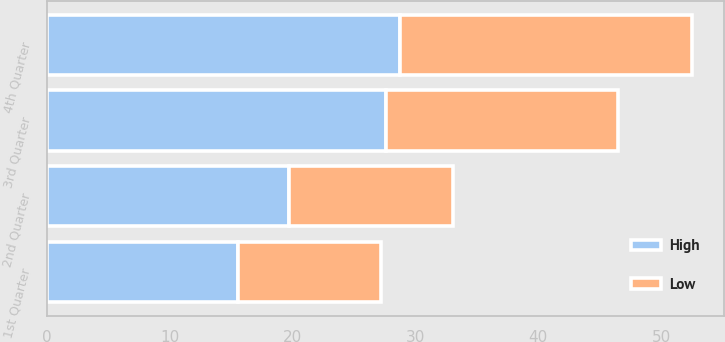<chart> <loc_0><loc_0><loc_500><loc_500><stacked_bar_chart><ecel><fcel>1st Quarter<fcel>2nd Quarter<fcel>3rd Quarter<fcel>4th Quarter<nl><fcel>High<fcel>15.55<fcel>19.7<fcel>27.6<fcel>28.74<nl><fcel>Low<fcel>11.62<fcel>13.36<fcel>18.85<fcel>23.75<nl></chart> 